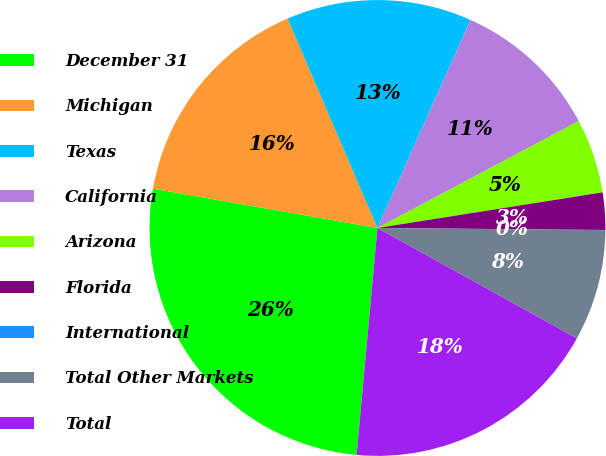Convert chart. <chart><loc_0><loc_0><loc_500><loc_500><pie_chart><fcel>December 31<fcel>Michigan<fcel>Texas<fcel>California<fcel>Arizona<fcel>Florida<fcel>International<fcel>Total Other Markets<fcel>Total<nl><fcel>26.3%<fcel>15.78%<fcel>13.16%<fcel>10.53%<fcel>5.27%<fcel>2.64%<fcel>0.01%<fcel>7.9%<fcel>18.41%<nl></chart> 